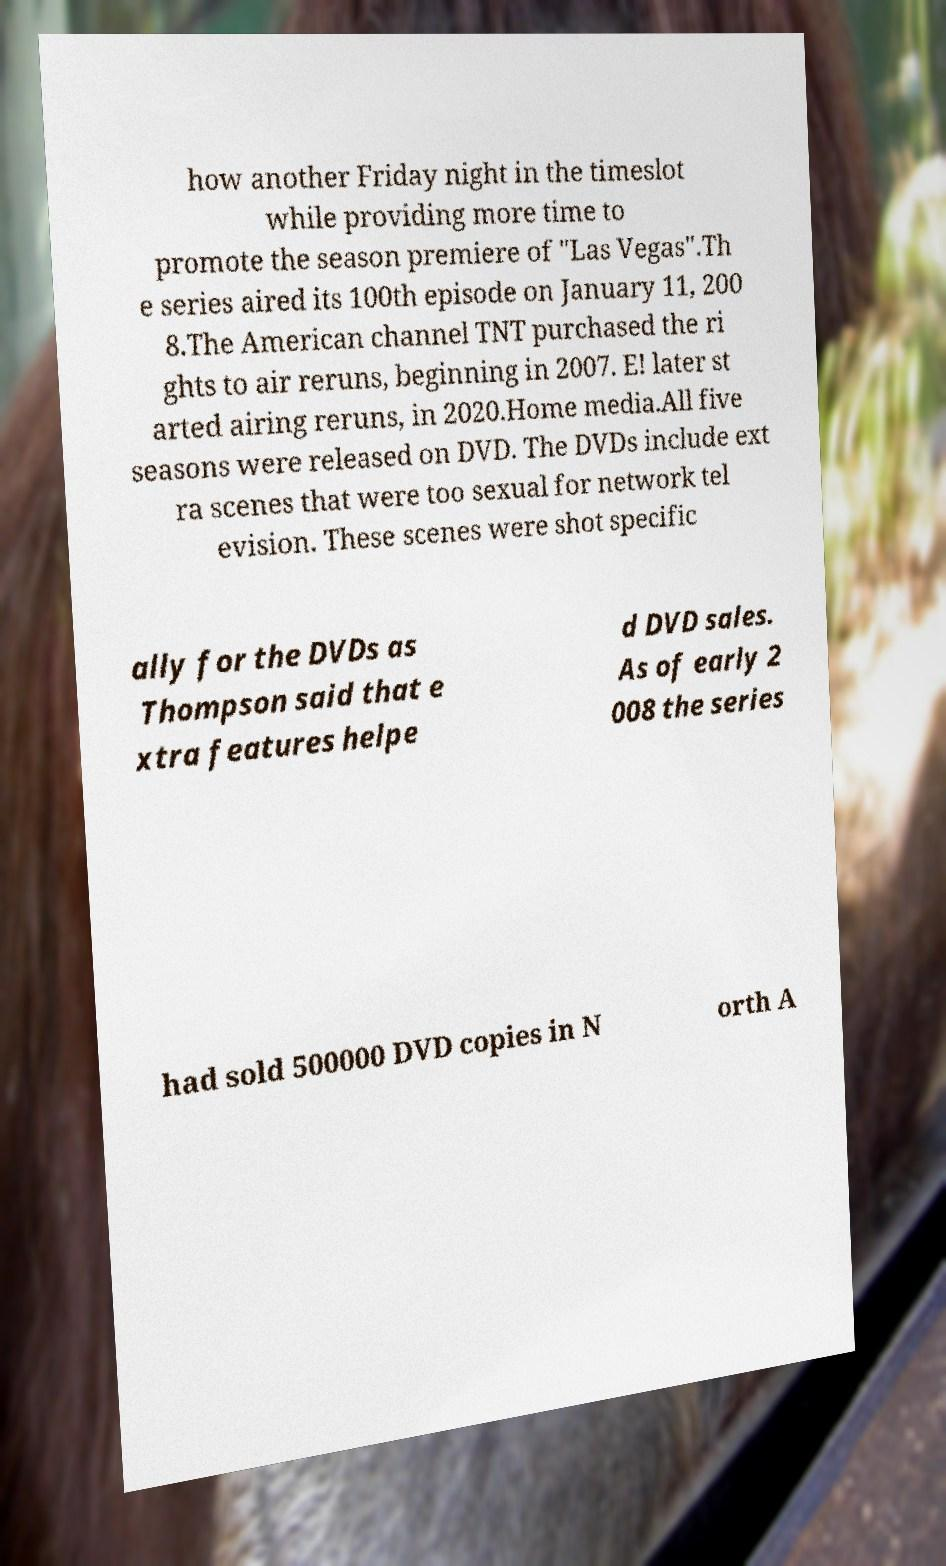I need the written content from this picture converted into text. Can you do that? how another Friday night in the timeslot while providing more time to promote the season premiere of "Las Vegas".Th e series aired its 100th episode on January 11, 200 8.The American channel TNT purchased the ri ghts to air reruns, beginning in 2007. E! later st arted airing reruns, in 2020.Home media.All five seasons were released on DVD. The DVDs include ext ra scenes that were too sexual for network tel evision. These scenes were shot specific ally for the DVDs as Thompson said that e xtra features helpe d DVD sales. As of early 2 008 the series had sold 500000 DVD copies in N orth A 